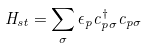Convert formula to latex. <formula><loc_0><loc_0><loc_500><loc_500>H _ { s t } = \sum _ { \sigma } \epsilon _ { p } c _ { p \sigma } ^ { \dagger } c _ { p \sigma } \,</formula> 